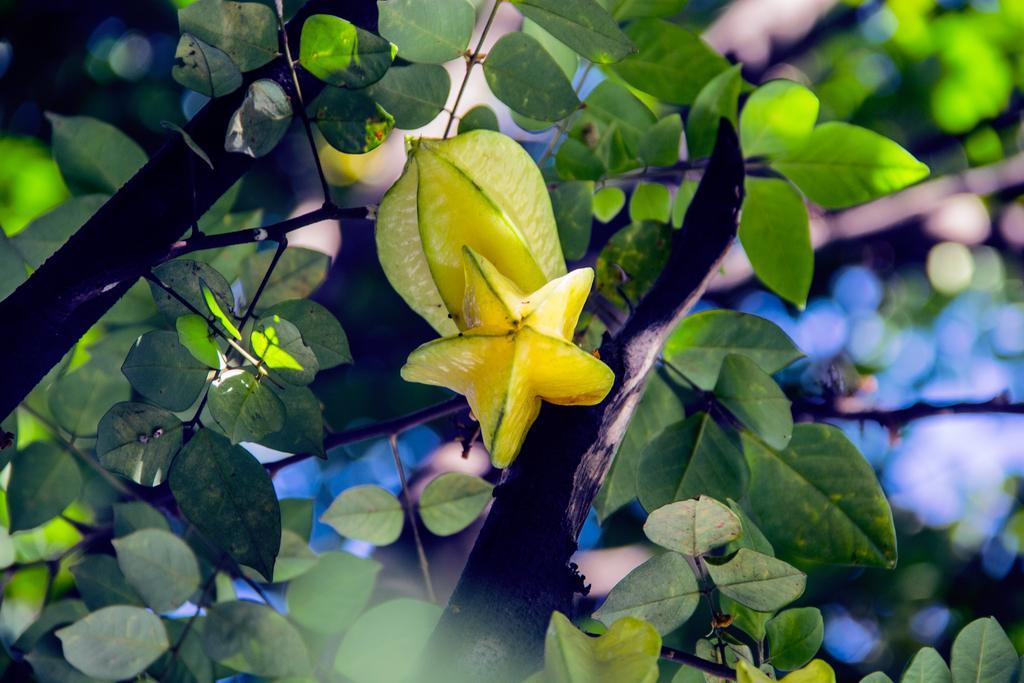Please provide a concise description of this image. This is the zoom-in picture of branch of a tree where we can see bark, leaves and flower. 